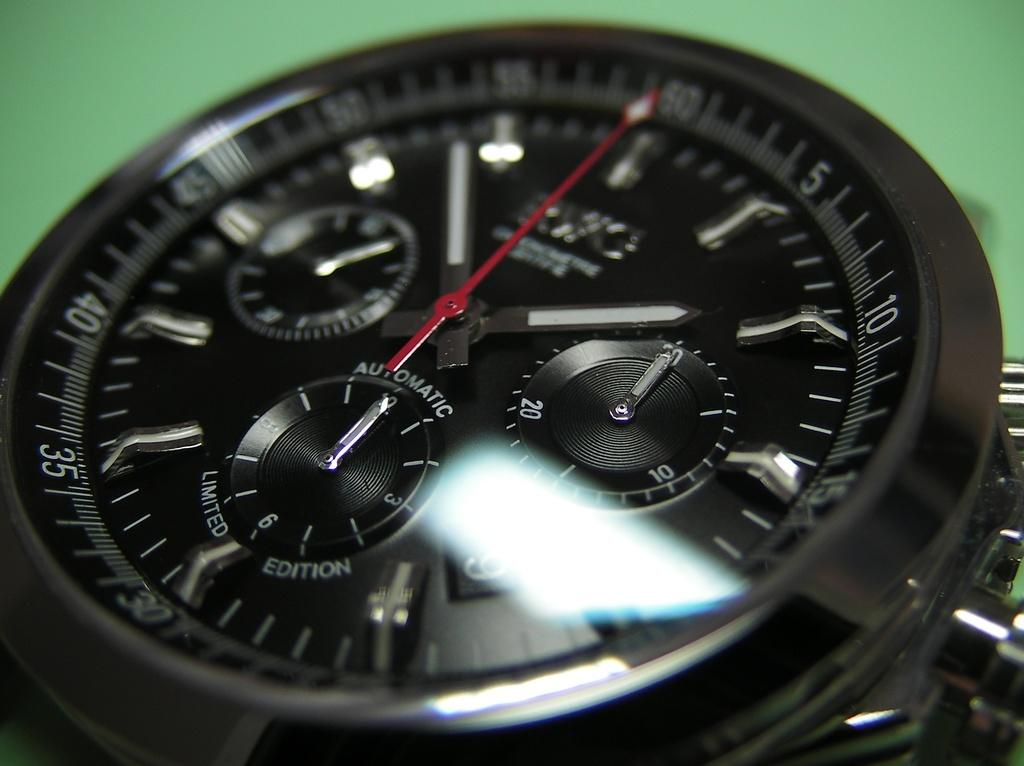Provide a one-sentence caption for the provided image. A round black watch face with the word automatic on it. 